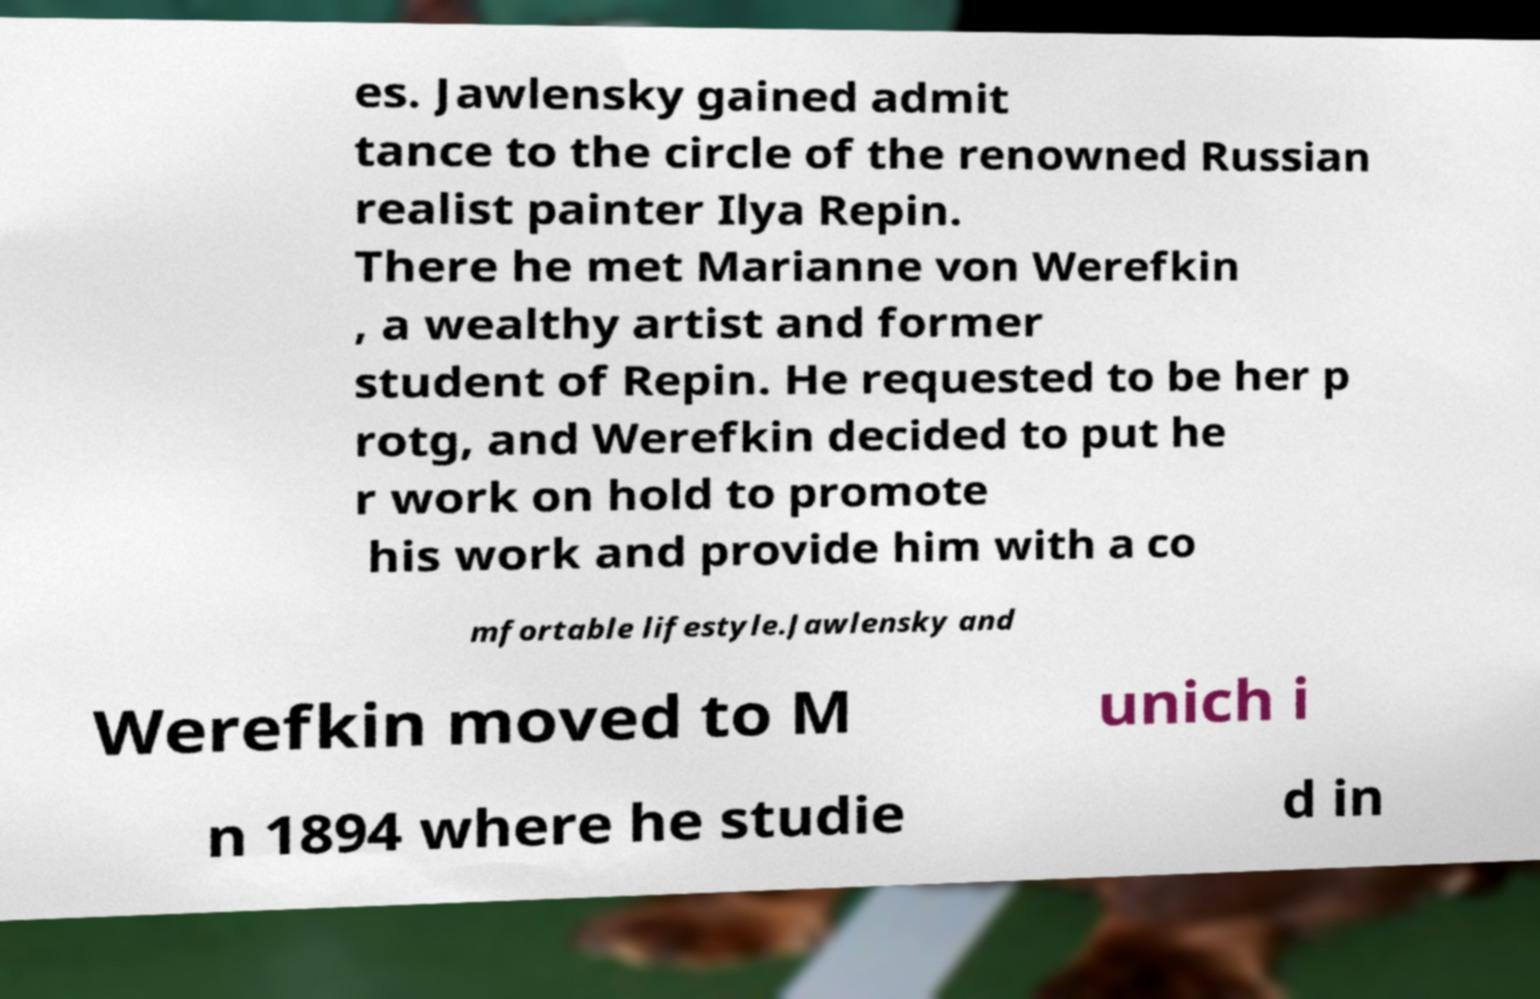What messages or text are displayed in this image? I need them in a readable, typed format. es. Jawlensky gained admit tance to the circle of the renowned Russian realist painter Ilya Repin. There he met Marianne von Werefkin , a wealthy artist and former student of Repin. He requested to be her p rotg, and Werefkin decided to put he r work on hold to promote his work and provide him with a co mfortable lifestyle.Jawlensky and Werefkin moved to M unich i n 1894 where he studie d in 